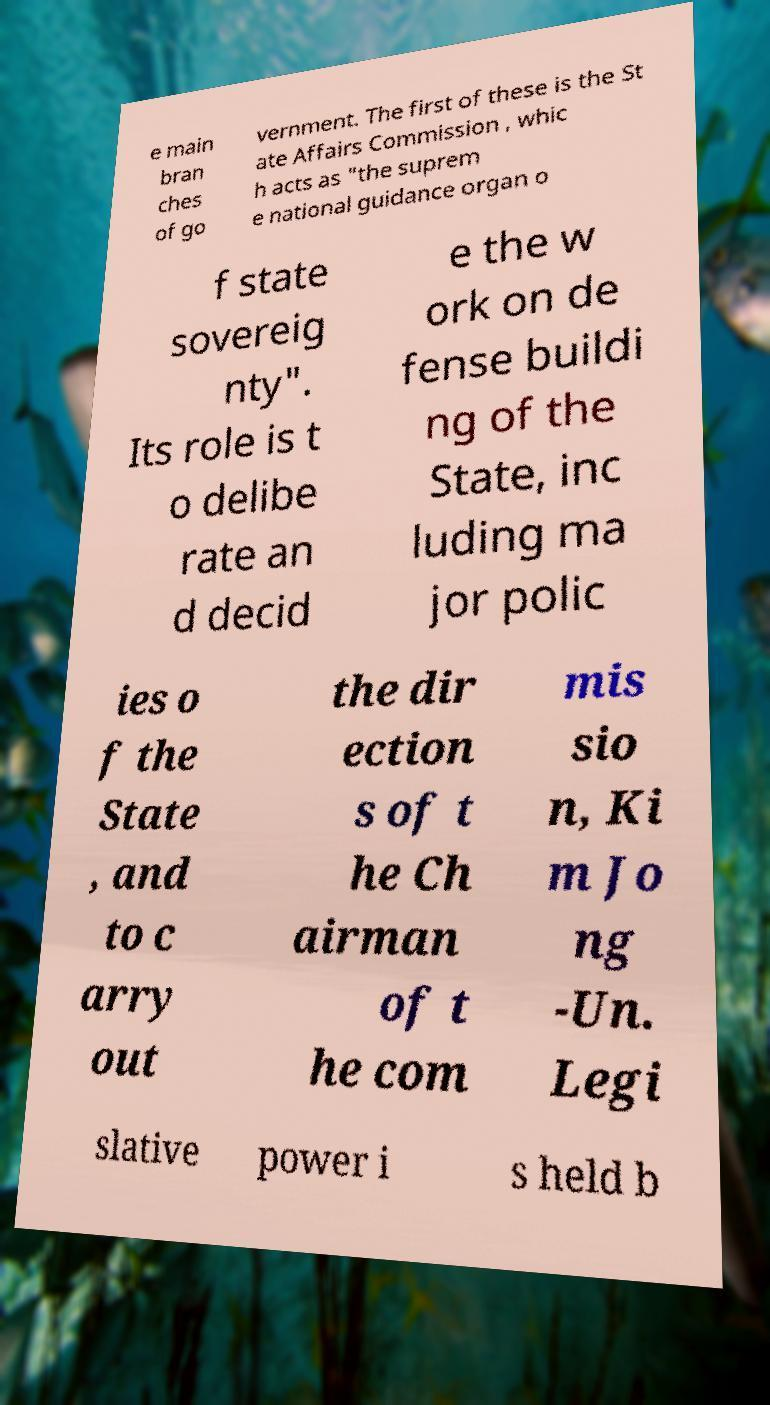Please identify and transcribe the text found in this image. e main bran ches of go vernment. The first of these is the St ate Affairs Commission , whic h acts as "the suprem e national guidance organ o f state sovereig nty". Its role is t o delibe rate an d decid e the w ork on de fense buildi ng of the State, inc luding ma jor polic ies o f the State , and to c arry out the dir ection s of t he Ch airman of t he com mis sio n, Ki m Jo ng -Un. Legi slative power i s held b 